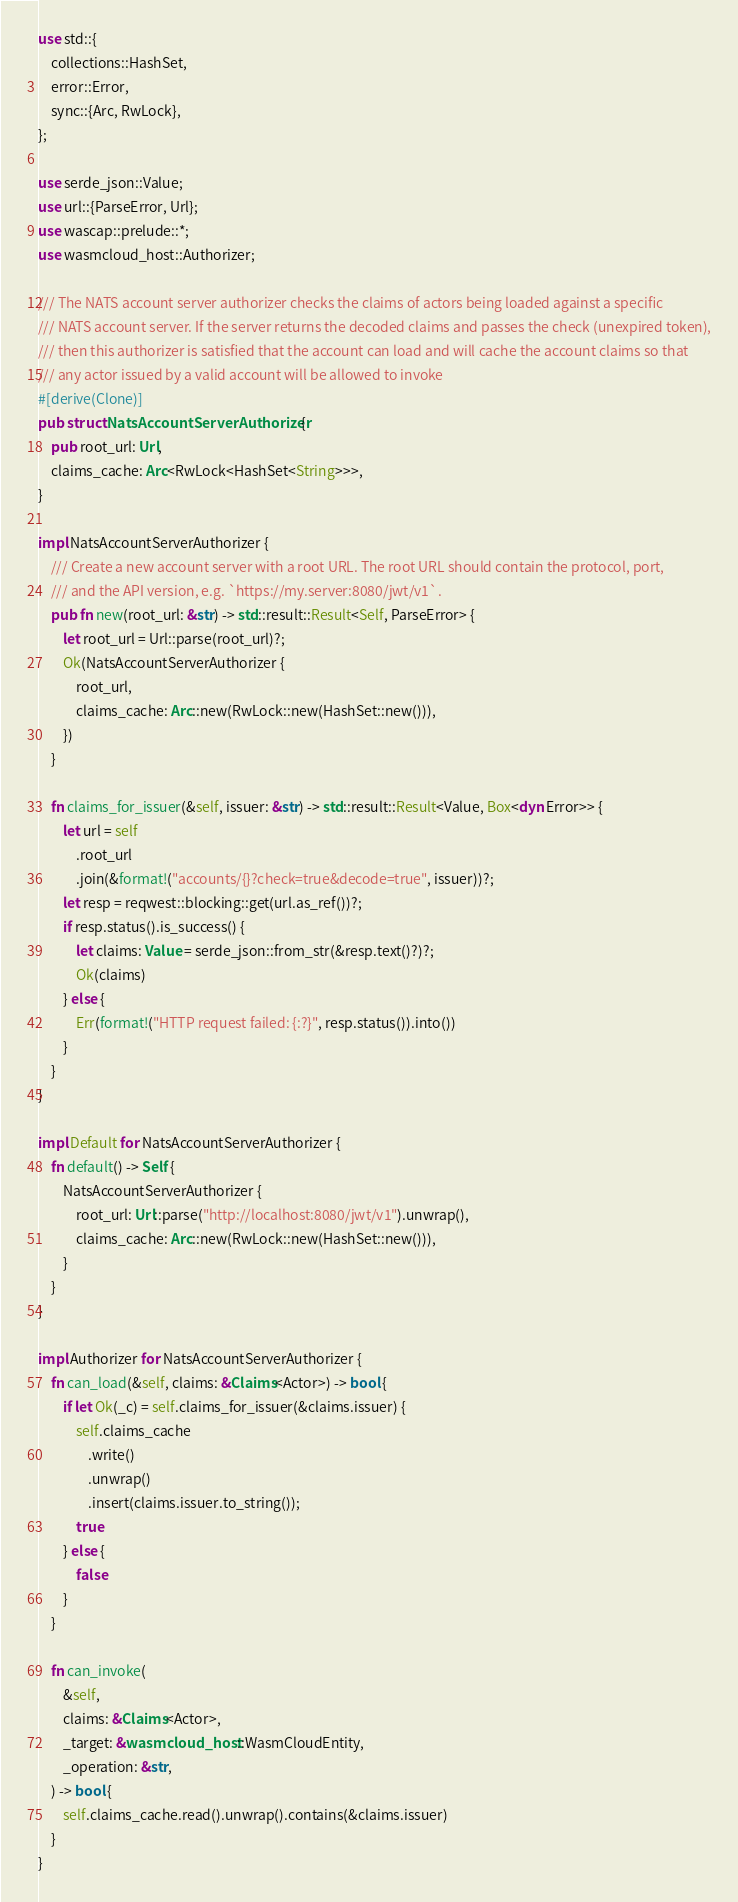Convert code to text. <code><loc_0><loc_0><loc_500><loc_500><_Rust_>use std::{
    collections::HashSet,
    error::Error,
    sync::{Arc, RwLock},
};

use serde_json::Value;
use url::{ParseError, Url};
use wascap::prelude::*;
use wasmcloud_host::Authorizer;

/// The NATS account server authorizer checks the claims of actors being loaded against a specific
/// NATS account server. If the server returns the decoded claims and passes the check (unexpired token),
/// then this authorizer is satisfied that the account can load and will cache the account claims so that
/// any actor issued by a valid account will be allowed to invoke
#[derive(Clone)]
pub struct NatsAccountServerAuthorizer {
    pub root_url: Url,
    claims_cache: Arc<RwLock<HashSet<String>>>,
}

impl NatsAccountServerAuthorizer {
    /// Create a new account server with a root URL. The root URL should contain the protocol, port,
    /// and the API version, e.g. `https://my.server:8080/jwt/v1`.
    pub fn new(root_url: &str) -> std::result::Result<Self, ParseError> {
        let root_url = Url::parse(root_url)?;
        Ok(NatsAccountServerAuthorizer {
            root_url,
            claims_cache: Arc::new(RwLock::new(HashSet::new())),
        })
    }

    fn claims_for_issuer(&self, issuer: &str) -> std::result::Result<Value, Box<dyn Error>> {
        let url = self
            .root_url
            .join(&format!("accounts/{}?check=true&decode=true", issuer))?;
        let resp = reqwest::blocking::get(url.as_ref())?;
        if resp.status().is_success() {
            let claims: Value = serde_json::from_str(&resp.text()?)?;
            Ok(claims)
        } else {
            Err(format!("HTTP request failed: {:?}", resp.status()).into())
        }
    }
}

impl Default for NatsAccountServerAuthorizer {
    fn default() -> Self {
        NatsAccountServerAuthorizer {
            root_url: Url::parse("http://localhost:8080/jwt/v1").unwrap(),
            claims_cache: Arc::new(RwLock::new(HashSet::new())),
        }
    }
}

impl Authorizer for NatsAccountServerAuthorizer {
    fn can_load(&self, claims: &Claims<Actor>) -> bool {
        if let Ok(_c) = self.claims_for_issuer(&claims.issuer) {
            self.claims_cache
                .write()
                .unwrap()
                .insert(claims.issuer.to_string());
            true
        } else {
            false
        }
    }

    fn can_invoke(
        &self,
        claims: &Claims<Actor>,
        _target: &wasmcloud_host::WasmCloudEntity,
        _operation: &str,
    ) -> bool {
        self.claims_cache.read().unwrap().contains(&claims.issuer)
    }
}
</code> 